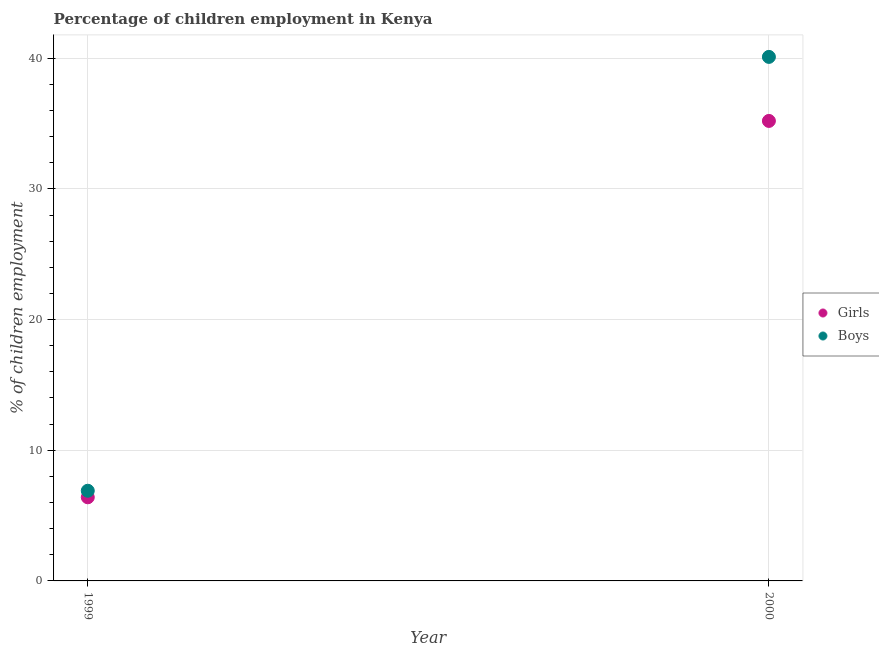Is the number of dotlines equal to the number of legend labels?
Give a very brief answer. Yes. What is the percentage of employed boys in 2000?
Your answer should be very brief. 40.1. Across all years, what is the maximum percentage of employed boys?
Provide a short and direct response. 40.1. In which year was the percentage of employed boys maximum?
Offer a terse response. 2000. In which year was the percentage of employed boys minimum?
Offer a terse response. 1999. What is the difference between the percentage of employed girls in 1999 and that in 2000?
Provide a succinct answer. -28.8. What is the difference between the percentage of employed boys in 1999 and the percentage of employed girls in 2000?
Your answer should be very brief. -28.3. What is the average percentage of employed girls per year?
Offer a terse response. 20.8. In the year 2000, what is the difference between the percentage of employed boys and percentage of employed girls?
Offer a terse response. 4.9. What is the ratio of the percentage of employed boys in 1999 to that in 2000?
Make the answer very short. 0.17. Is the percentage of employed girls strictly less than the percentage of employed boys over the years?
Your answer should be compact. Yes. How many dotlines are there?
Offer a terse response. 2. How many years are there in the graph?
Give a very brief answer. 2. Are the values on the major ticks of Y-axis written in scientific E-notation?
Provide a succinct answer. No. Does the graph contain grids?
Offer a terse response. Yes. Where does the legend appear in the graph?
Ensure brevity in your answer.  Center right. How many legend labels are there?
Give a very brief answer. 2. What is the title of the graph?
Your answer should be compact. Percentage of children employment in Kenya. What is the label or title of the Y-axis?
Provide a short and direct response. % of children employment. What is the % of children employment in Girls in 1999?
Your answer should be compact. 6.4. What is the % of children employment of Girls in 2000?
Your answer should be very brief. 35.2. What is the % of children employment in Boys in 2000?
Provide a short and direct response. 40.1. Across all years, what is the maximum % of children employment in Girls?
Provide a succinct answer. 35.2. Across all years, what is the maximum % of children employment in Boys?
Provide a short and direct response. 40.1. Across all years, what is the minimum % of children employment in Girls?
Provide a succinct answer. 6.4. What is the total % of children employment in Girls in the graph?
Ensure brevity in your answer.  41.6. What is the total % of children employment in Boys in the graph?
Your answer should be compact. 47. What is the difference between the % of children employment of Girls in 1999 and that in 2000?
Ensure brevity in your answer.  -28.8. What is the difference between the % of children employment in Boys in 1999 and that in 2000?
Offer a very short reply. -33.2. What is the difference between the % of children employment of Girls in 1999 and the % of children employment of Boys in 2000?
Your answer should be very brief. -33.7. What is the average % of children employment in Girls per year?
Your response must be concise. 20.8. What is the average % of children employment in Boys per year?
Your answer should be very brief. 23.5. In the year 2000, what is the difference between the % of children employment of Girls and % of children employment of Boys?
Provide a succinct answer. -4.9. What is the ratio of the % of children employment of Girls in 1999 to that in 2000?
Give a very brief answer. 0.18. What is the ratio of the % of children employment of Boys in 1999 to that in 2000?
Provide a succinct answer. 0.17. What is the difference between the highest and the second highest % of children employment in Girls?
Keep it short and to the point. 28.8. What is the difference between the highest and the second highest % of children employment in Boys?
Your answer should be very brief. 33.2. What is the difference between the highest and the lowest % of children employment in Girls?
Provide a succinct answer. 28.8. What is the difference between the highest and the lowest % of children employment in Boys?
Keep it short and to the point. 33.2. 